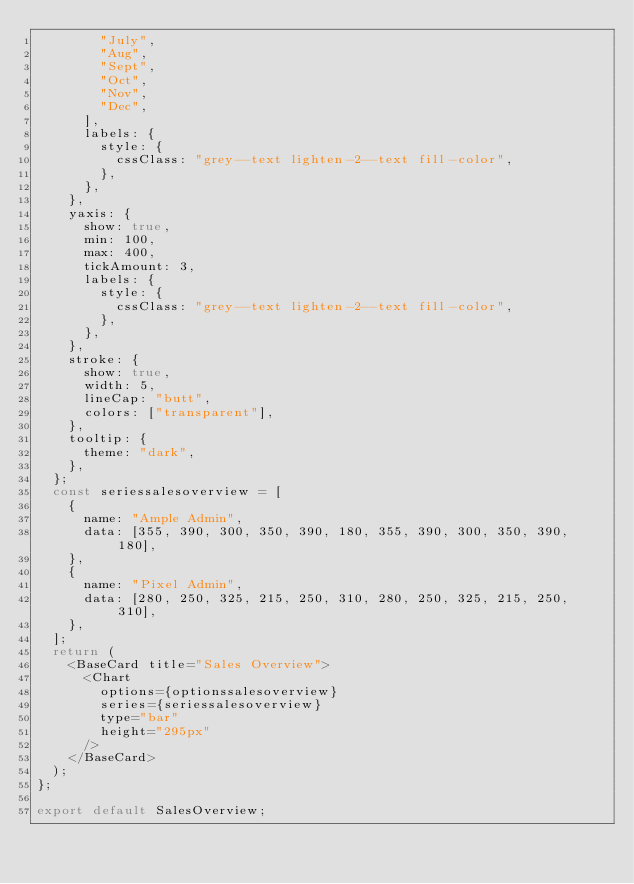Convert code to text. <code><loc_0><loc_0><loc_500><loc_500><_JavaScript_>        "July",
        "Aug",
        "Sept",
        "Oct",
        "Nov",
        "Dec",
      ],
      labels: {
        style: {
          cssClass: "grey--text lighten-2--text fill-color",
        },
      },
    },
    yaxis: {
      show: true,
      min: 100,
      max: 400,
      tickAmount: 3,
      labels: {
        style: {
          cssClass: "grey--text lighten-2--text fill-color",
        },
      },
    },
    stroke: {
      show: true,
      width: 5,
      lineCap: "butt",
      colors: ["transparent"],
    },
    tooltip: {
      theme: "dark",
    },
  };
  const seriessalesoverview = [
    {
      name: "Ample Admin",
      data: [355, 390, 300, 350, 390, 180, 355, 390, 300, 350, 390, 180],
    },
    {
      name: "Pixel Admin",
      data: [280, 250, 325, 215, 250, 310, 280, 250, 325, 215, 250, 310],
    },
  ];
  return (
    <BaseCard title="Sales Overview">
      <Chart
        options={optionssalesoverview}
        series={seriessalesoverview}
        type="bar"
        height="295px"
      />
    </BaseCard>
  );
};

export default SalesOverview;
</code> 